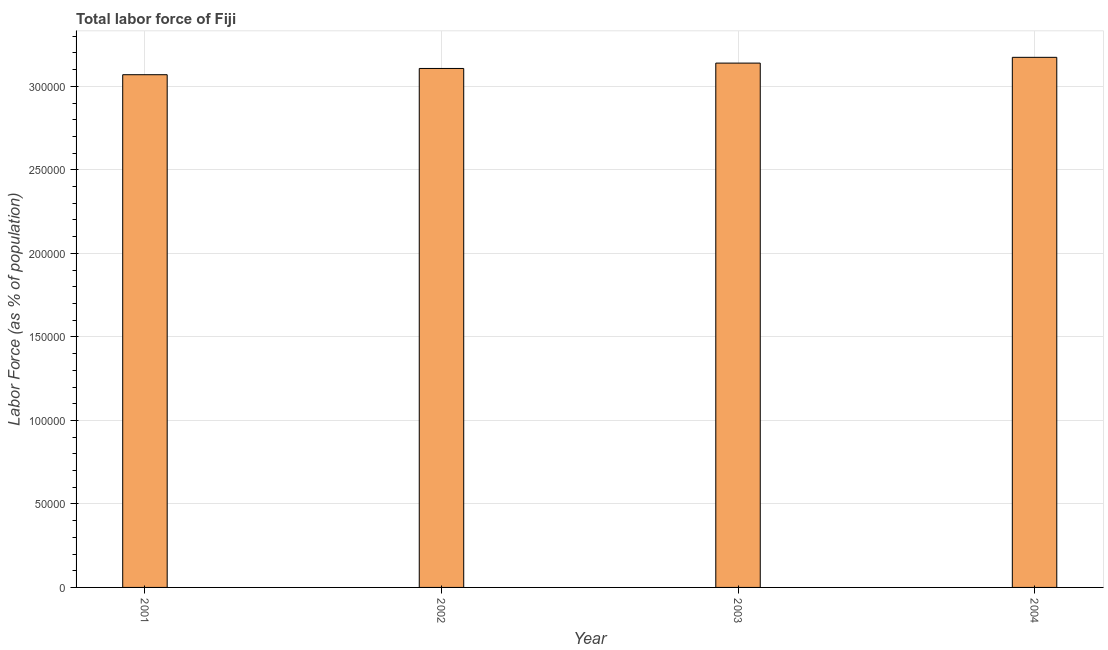Does the graph contain any zero values?
Make the answer very short. No. What is the title of the graph?
Your answer should be very brief. Total labor force of Fiji. What is the label or title of the Y-axis?
Provide a short and direct response. Labor Force (as % of population). What is the total labor force in 2002?
Provide a short and direct response. 3.11e+05. Across all years, what is the maximum total labor force?
Keep it short and to the point. 3.17e+05. Across all years, what is the minimum total labor force?
Offer a terse response. 3.07e+05. In which year was the total labor force maximum?
Make the answer very short. 2004. In which year was the total labor force minimum?
Keep it short and to the point. 2001. What is the sum of the total labor force?
Offer a very short reply. 1.25e+06. What is the difference between the total labor force in 2002 and 2003?
Your answer should be compact. -3204. What is the average total labor force per year?
Give a very brief answer. 3.12e+05. What is the median total labor force?
Ensure brevity in your answer.  3.12e+05. In how many years, is the total labor force greater than 10000 %?
Your response must be concise. 4. Do a majority of the years between 2001 and 2004 (inclusive) have total labor force greater than 40000 %?
Your response must be concise. Yes. What is the ratio of the total labor force in 2001 to that in 2004?
Make the answer very short. 0.97. Is the total labor force in 2003 less than that in 2004?
Provide a succinct answer. Yes. What is the difference between the highest and the second highest total labor force?
Keep it short and to the point. 3457. Is the sum of the total labor force in 2002 and 2004 greater than the maximum total labor force across all years?
Your response must be concise. Yes. What is the difference between the highest and the lowest total labor force?
Give a very brief answer. 1.04e+04. In how many years, is the total labor force greater than the average total labor force taken over all years?
Your answer should be very brief. 2. What is the Labor Force (as % of population) in 2001?
Give a very brief answer. 3.07e+05. What is the Labor Force (as % of population) in 2002?
Give a very brief answer. 3.11e+05. What is the Labor Force (as % of population) of 2003?
Give a very brief answer. 3.14e+05. What is the Labor Force (as % of population) of 2004?
Give a very brief answer. 3.17e+05. What is the difference between the Labor Force (as % of population) in 2001 and 2002?
Ensure brevity in your answer.  -3749. What is the difference between the Labor Force (as % of population) in 2001 and 2003?
Your response must be concise. -6953. What is the difference between the Labor Force (as % of population) in 2001 and 2004?
Ensure brevity in your answer.  -1.04e+04. What is the difference between the Labor Force (as % of population) in 2002 and 2003?
Your answer should be compact. -3204. What is the difference between the Labor Force (as % of population) in 2002 and 2004?
Provide a succinct answer. -6661. What is the difference between the Labor Force (as % of population) in 2003 and 2004?
Offer a very short reply. -3457. What is the ratio of the Labor Force (as % of population) in 2001 to that in 2002?
Your answer should be compact. 0.99. What is the ratio of the Labor Force (as % of population) in 2001 to that in 2004?
Your response must be concise. 0.97. What is the ratio of the Labor Force (as % of population) in 2002 to that in 2003?
Your answer should be compact. 0.99. What is the ratio of the Labor Force (as % of population) in 2002 to that in 2004?
Keep it short and to the point. 0.98. What is the ratio of the Labor Force (as % of population) in 2003 to that in 2004?
Offer a terse response. 0.99. 